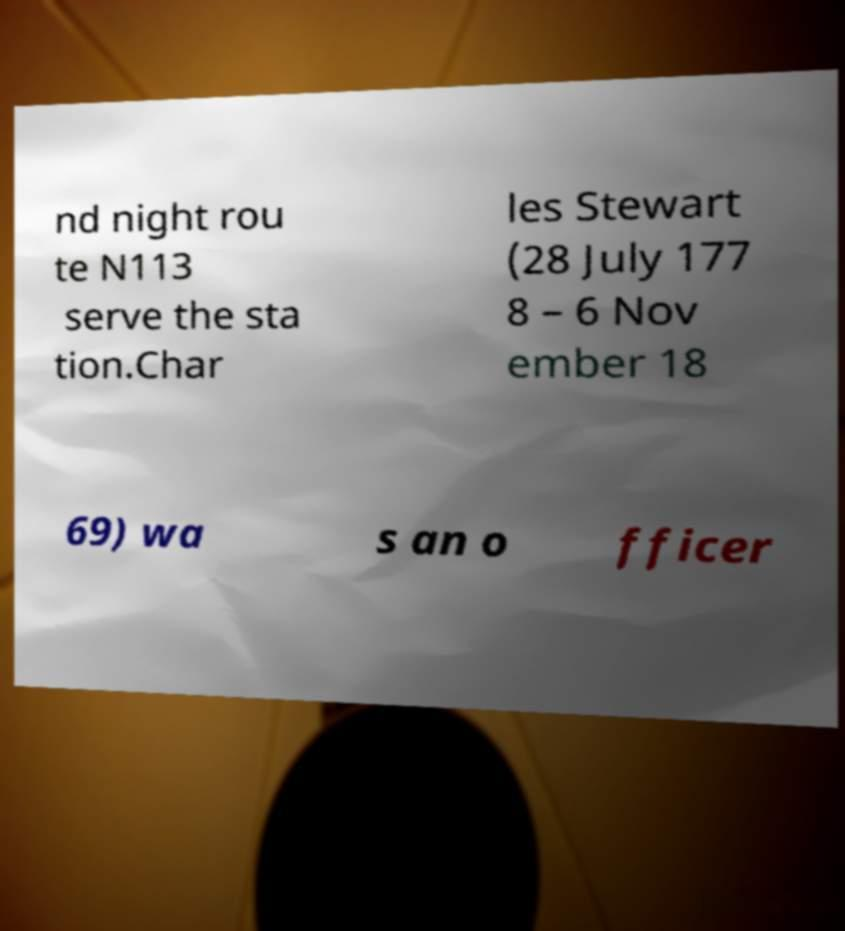There's text embedded in this image that I need extracted. Can you transcribe it verbatim? nd night rou te N113 serve the sta tion.Char les Stewart (28 July 177 8 – 6 Nov ember 18 69) wa s an o fficer 